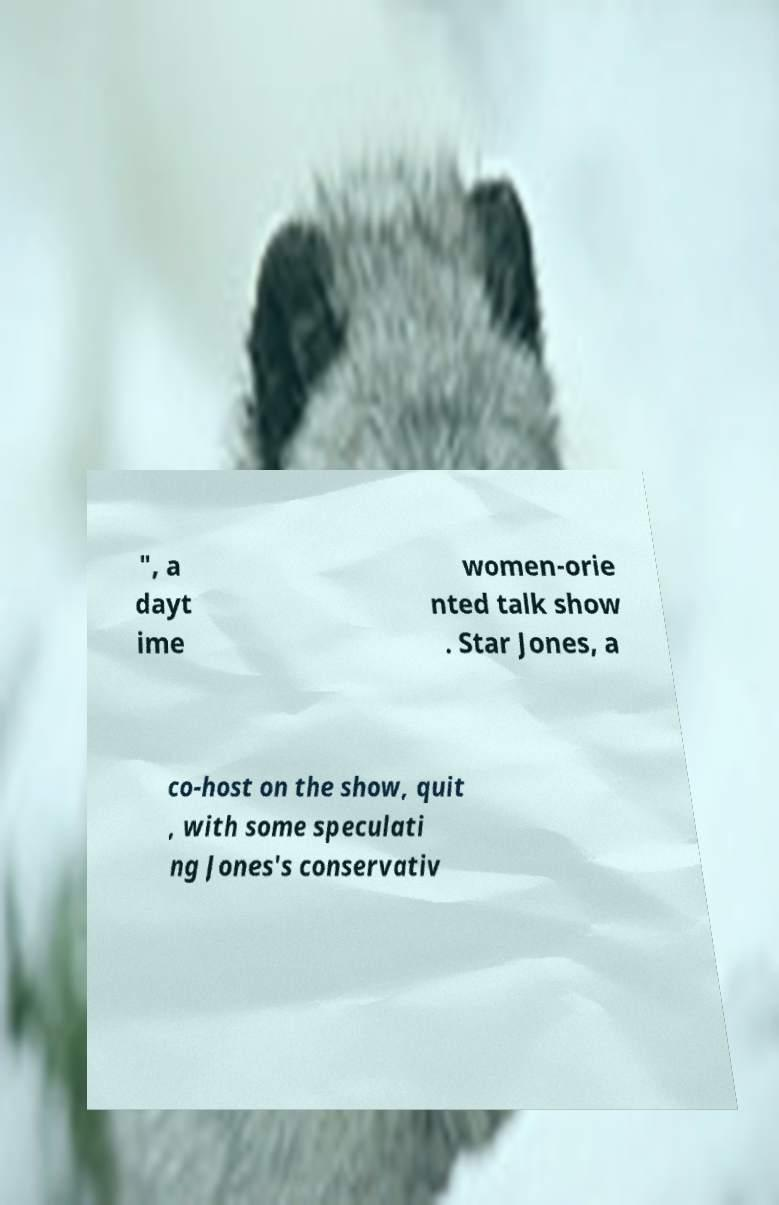There's text embedded in this image that I need extracted. Can you transcribe it verbatim? ", a dayt ime women-orie nted talk show . Star Jones, a co-host on the show, quit , with some speculati ng Jones's conservativ 